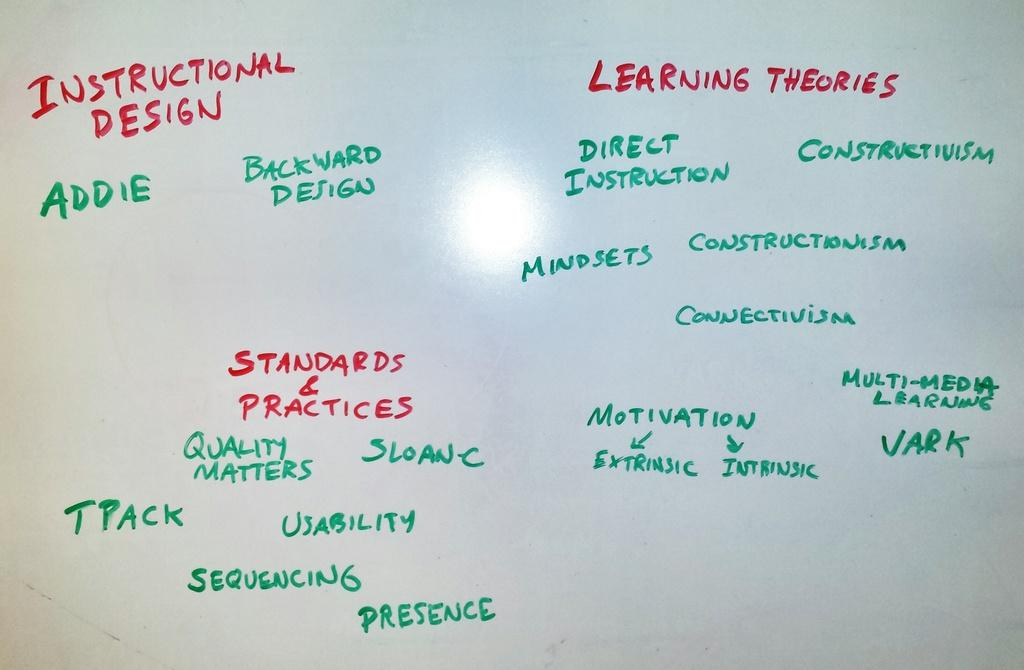<image>
Share a concise interpretation of the image provided. A list of learning theories written on a white board. 